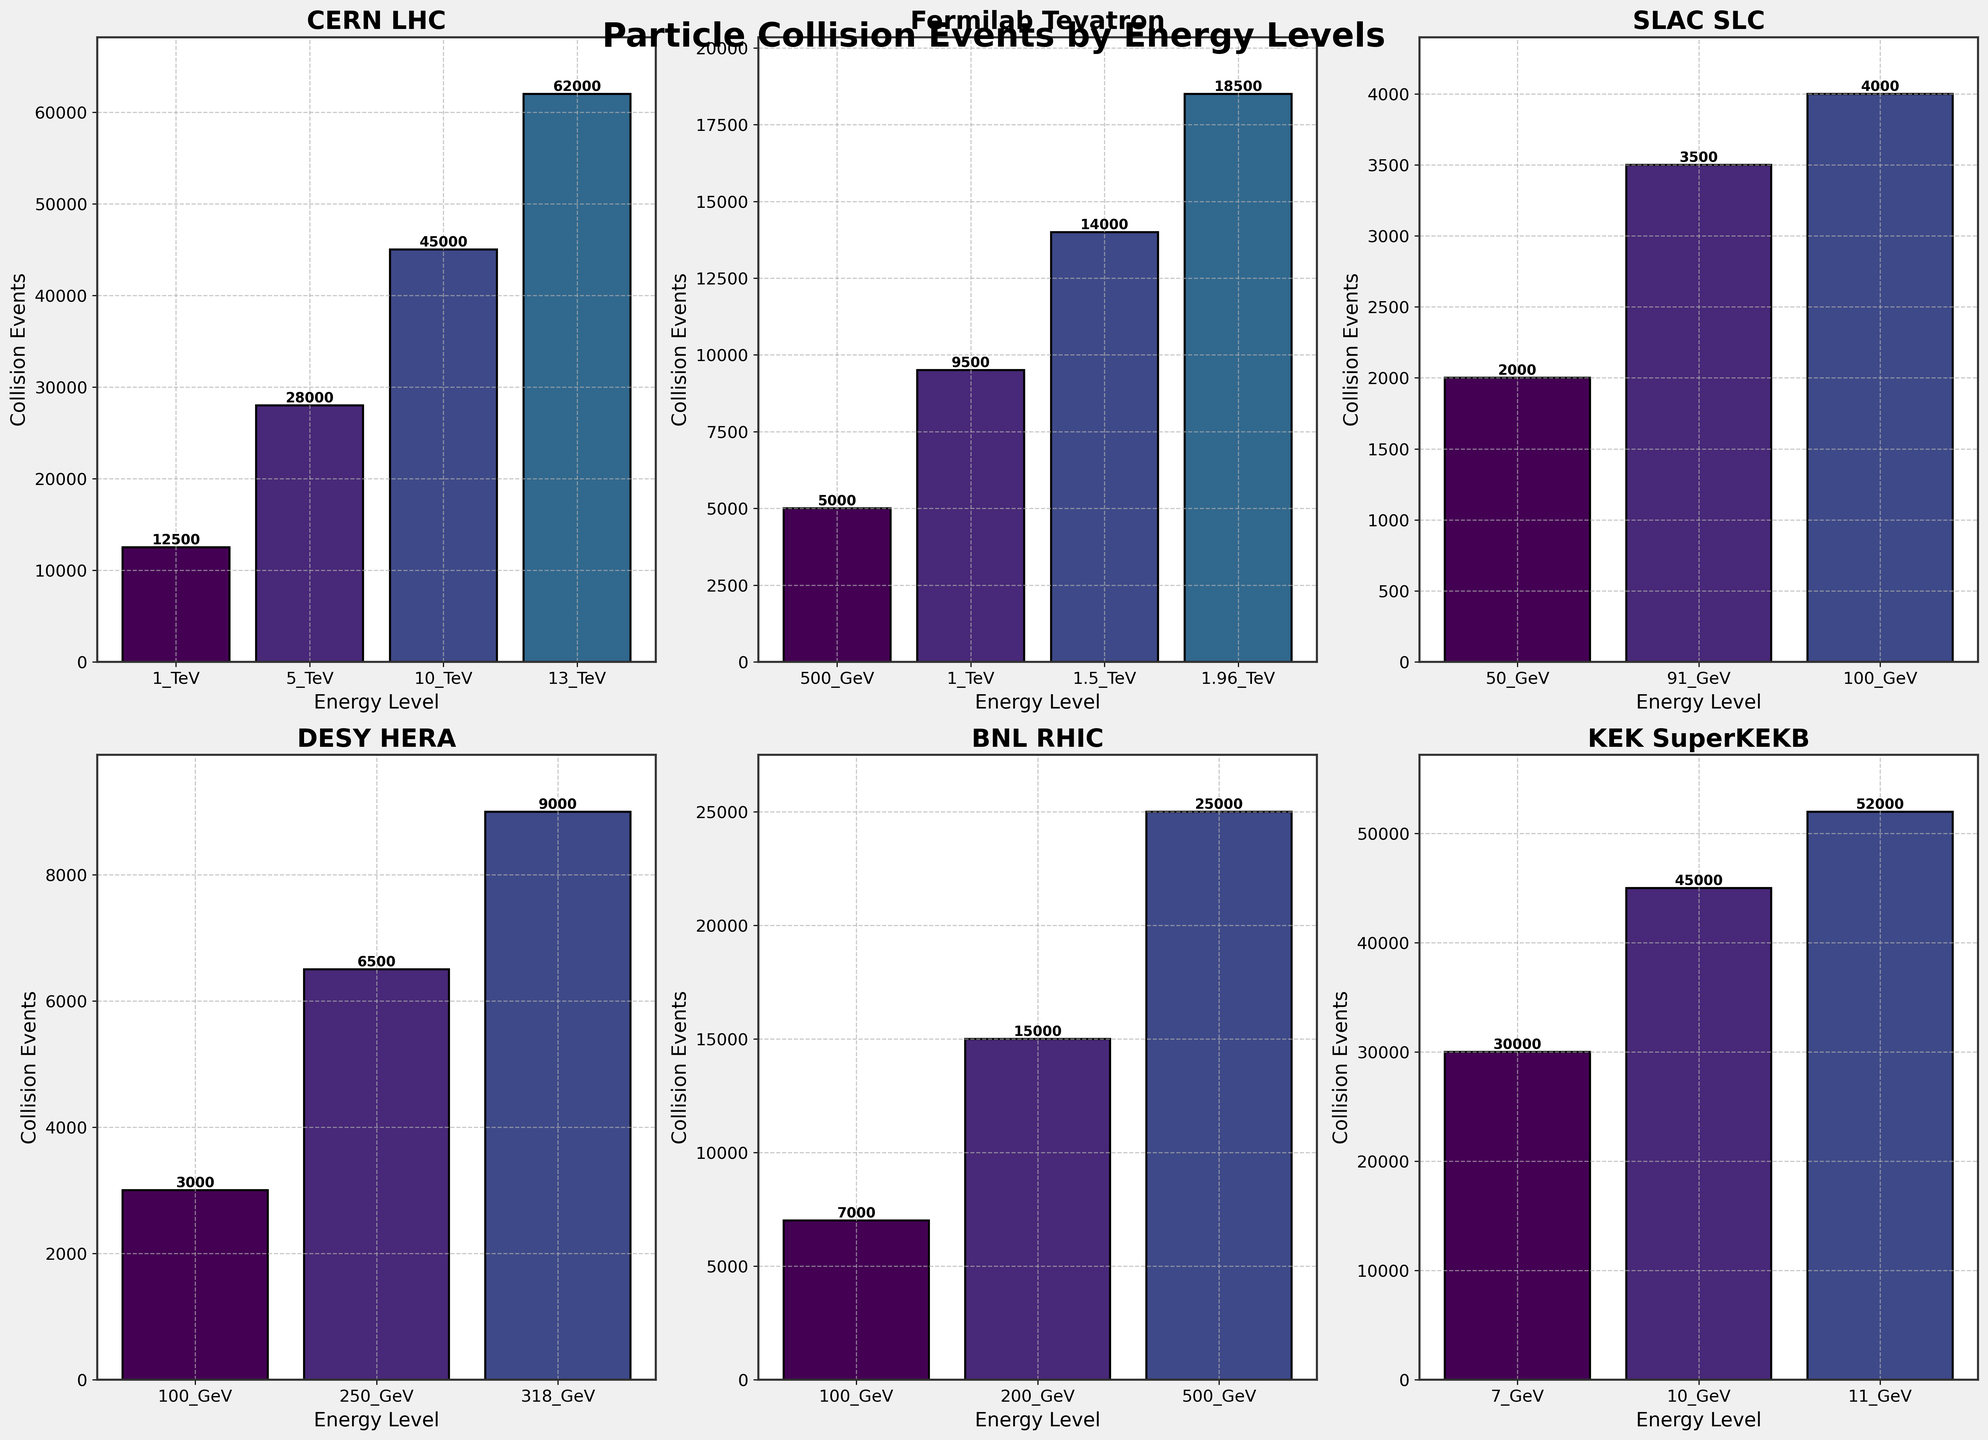Which facility has the highest number of collision events at its highest energy level? The CERN LHC has the highest number of collision events at its highest energy level of 13 TeV, totaling 62,000 events. Locate the highest energy level in each subplot and compare the event counts.
Answer: CERN LHC Compare the number of collision events at the 1 TeV energy level between CERN LHC and Fermilab Tevatron. Which has more? CERN LHC has 12,500 collision events at 1 TeV, whereas Fermilab Tevatron has 9,500 collision events at 1 TeV. One can directly compare these values from the subplots for these facilities.
Answer: CERN LHC What is the total number of collision events recorded by KEK SuperKEKB? Adding the collision events at 7 GeV (30,000), 10 GeV (45,000), and 11 GeV (52,000) gives a total of 127,000.
Answer: 127,000 Which facility has the lowest collision events at any given energy level, and what is that value? SLAC SLC at 50 GeV has the lowest number of collision events with a value of 2,000. This can be observed by identifying the shortest bar across all subplots.
Answer: SLAC SLC, 2000 What is the average number of collision events at all energy levels for Fermilab Tevatron? Summing the collision events for Fermilab Tevatron (5,000 + 9,500 + 14,000 + 18,500) gives 47,000. Dividing this sum by 4 (the number of energy levels) results in an average of 11,750.
Answer: 11,750 How do the collision events at the highest energy level for DESY HERA compare to that of BNL RHIC? DESY HERA's highest energy level (318 GeV) has 9,000 collision events, while BNL RHIC's highest energy level (500 GeV) has 25,000 collision events. Comparing these values shows that BNL RHIC has significantly more events.
Answer: BNL RHIC has more Are there any facilities where the number of collision events decreases with an increase in energy level? By examining the subplots, all facilities show an increase or fluctuation in collision events with increasing energy levels; no facility shows a consistent decrease.
Answer: No What is the difference in the number of collision events between 1 TeV at CERN LHC and 1 TeV at Fermilab Tevatron? CERN LHC has 12,500 events at 1 TeV, and Fermilab Tevatron has 9,500 events at 1 TeV. The difference is 12,500 - 9,500 = 3,000.
Answer: 3,000 How many facilities have their highest collision events at an energy level above 10 GeV? CERN LHC, KEK SuperKEKB, and BNL RHIC have their highest collision events at energy levels above 10 GeV. Count the facilities where the highest energy level bar in the subplot exceeds 10 GeV.
Answer: 3 